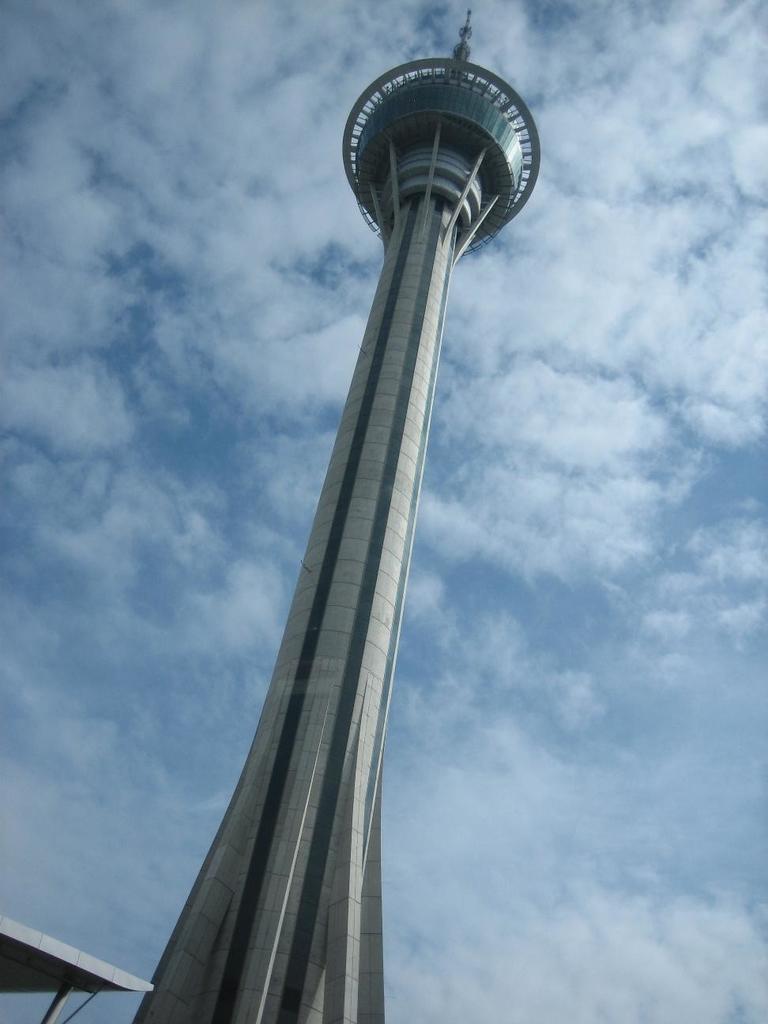In one or two sentences, can you explain what this image depicts? Here in this picture we can see a tower present on the ground over there and we can see the sky is full of clouds over there. 